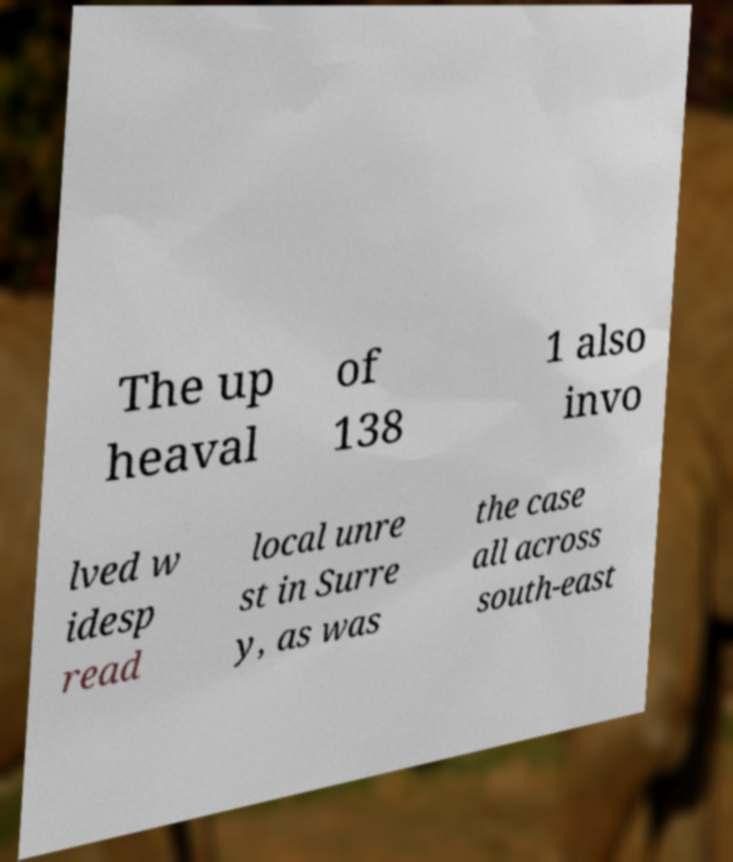Please identify and transcribe the text found in this image. The up heaval of 138 1 also invo lved w idesp read local unre st in Surre y, as was the case all across south-east 